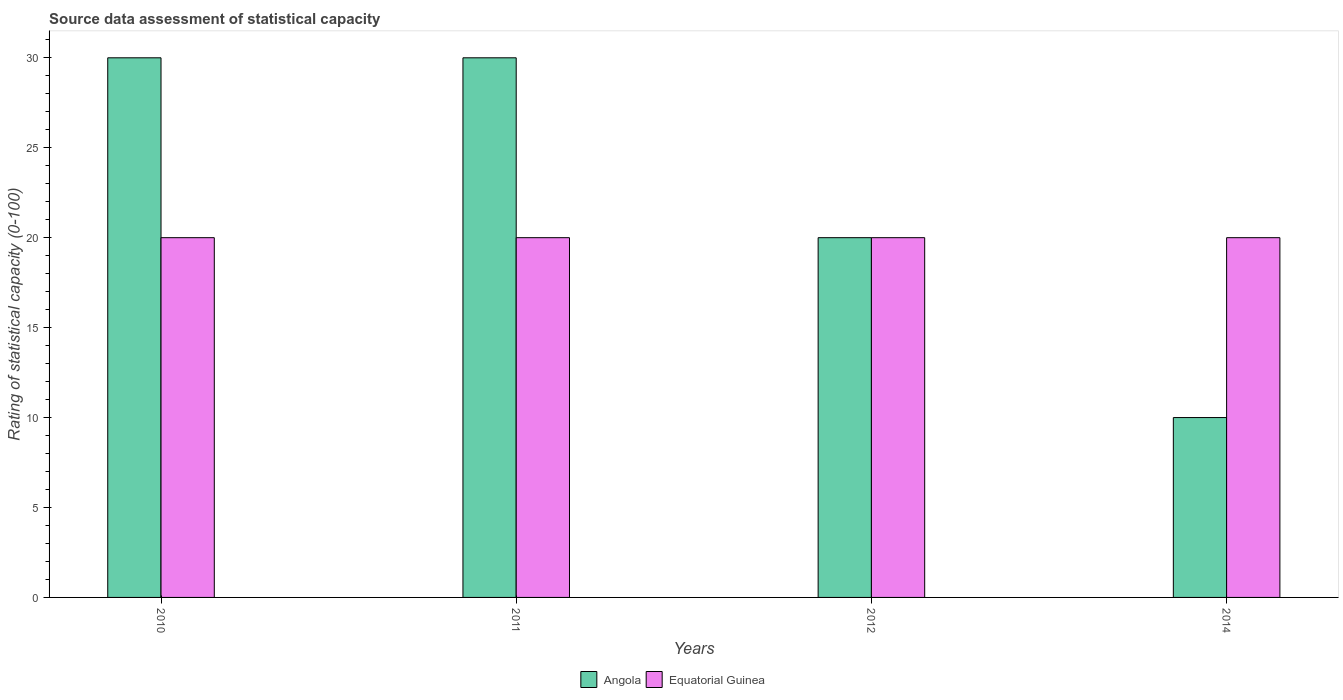How many groups of bars are there?
Your answer should be very brief. 4. How many bars are there on the 2nd tick from the right?
Provide a short and direct response. 2. In how many cases, is the number of bars for a given year not equal to the number of legend labels?
Keep it short and to the point. 0. What is the rating of statistical capacity in Angola in 2011?
Your response must be concise. 30. Across all years, what is the maximum rating of statistical capacity in Angola?
Make the answer very short. 30. Across all years, what is the minimum rating of statistical capacity in Angola?
Make the answer very short. 10. In which year was the rating of statistical capacity in Angola maximum?
Make the answer very short. 2010. What is the difference between the rating of statistical capacity in Equatorial Guinea in 2010 and that in 2011?
Ensure brevity in your answer.  0. What is the difference between the rating of statistical capacity in Equatorial Guinea in 2010 and the rating of statistical capacity in Angola in 2012?
Offer a terse response. 0. In the year 2012, what is the difference between the rating of statistical capacity in Angola and rating of statistical capacity in Equatorial Guinea?
Ensure brevity in your answer.  0. In how many years, is the rating of statistical capacity in Angola greater than 15?
Ensure brevity in your answer.  3. What is the ratio of the rating of statistical capacity in Equatorial Guinea in 2010 to that in 2011?
Your answer should be compact. 1. Is the rating of statistical capacity in Angola in 2010 less than that in 2012?
Your response must be concise. No. Is the difference between the rating of statistical capacity in Angola in 2010 and 2012 greater than the difference between the rating of statistical capacity in Equatorial Guinea in 2010 and 2012?
Provide a succinct answer. Yes. In how many years, is the rating of statistical capacity in Equatorial Guinea greater than the average rating of statistical capacity in Equatorial Guinea taken over all years?
Provide a succinct answer. 0. Is the sum of the rating of statistical capacity in Equatorial Guinea in 2012 and 2014 greater than the maximum rating of statistical capacity in Angola across all years?
Offer a very short reply. Yes. What does the 2nd bar from the left in 2012 represents?
Provide a short and direct response. Equatorial Guinea. What does the 2nd bar from the right in 2010 represents?
Give a very brief answer. Angola. How many bars are there?
Ensure brevity in your answer.  8. Are all the bars in the graph horizontal?
Provide a short and direct response. No. Are the values on the major ticks of Y-axis written in scientific E-notation?
Your answer should be compact. No. Does the graph contain any zero values?
Provide a succinct answer. No. Does the graph contain grids?
Your answer should be very brief. No. Where does the legend appear in the graph?
Your response must be concise. Bottom center. What is the title of the graph?
Your answer should be compact. Source data assessment of statistical capacity. Does "Burundi" appear as one of the legend labels in the graph?
Make the answer very short. No. What is the label or title of the X-axis?
Ensure brevity in your answer.  Years. What is the label or title of the Y-axis?
Ensure brevity in your answer.  Rating of statistical capacity (0-100). What is the Rating of statistical capacity (0-100) of Angola in 2012?
Your response must be concise. 20. What is the Rating of statistical capacity (0-100) in Angola in 2014?
Provide a succinct answer. 10. What is the Rating of statistical capacity (0-100) in Equatorial Guinea in 2014?
Your response must be concise. 20. Across all years, what is the maximum Rating of statistical capacity (0-100) of Angola?
Ensure brevity in your answer.  30. Across all years, what is the maximum Rating of statistical capacity (0-100) of Equatorial Guinea?
Offer a terse response. 20. What is the difference between the Rating of statistical capacity (0-100) of Equatorial Guinea in 2010 and that in 2011?
Give a very brief answer. 0. What is the difference between the Rating of statistical capacity (0-100) of Equatorial Guinea in 2010 and that in 2014?
Your response must be concise. 0. What is the difference between the Rating of statistical capacity (0-100) of Angola in 2011 and that in 2012?
Give a very brief answer. 10. What is the difference between the Rating of statistical capacity (0-100) of Angola in 2011 and that in 2014?
Your answer should be very brief. 20. What is the difference between the Rating of statistical capacity (0-100) of Equatorial Guinea in 2011 and that in 2014?
Ensure brevity in your answer.  0. What is the difference between the Rating of statistical capacity (0-100) in Equatorial Guinea in 2012 and that in 2014?
Offer a very short reply. 0. What is the difference between the Rating of statistical capacity (0-100) of Angola in 2010 and the Rating of statistical capacity (0-100) of Equatorial Guinea in 2014?
Keep it short and to the point. 10. What is the difference between the Rating of statistical capacity (0-100) of Angola in 2011 and the Rating of statistical capacity (0-100) of Equatorial Guinea in 2012?
Give a very brief answer. 10. What is the difference between the Rating of statistical capacity (0-100) of Angola in 2011 and the Rating of statistical capacity (0-100) of Equatorial Guinea in 2014?
Give a very brief answer. 10. What is the ratio of the Rating of statistical capacity (0-100) of Equatorial Guinea in 2010 to that in 2011?
Make the answer very short. 1. What is the ratio of the Rating of statistical capacity (0-100) in Angola in 2010 to that in 2012?
Your answer should be very brief. 1.5. What is the ratio of the Rating of statistical capacity (0-100) of Angola in 2010 to that in 2014?
Make the answer very short. 3. What is the ratio of the Rating of statistical capacity (0-100) of Angola in 2011 to that in 2012?
Ensure brevity in your answer.  1.5. What is the ratio of the Rating of statistical capacity (0-100) in Angola in 2011 to that in 2014?
Provide a succinct answer. 3. What is the ratio of the Rating of statistical capacity (0-100) of Equatorial Guinea in 2011 to that in 2014?
Give a very brief answer. 1. What is the ratio of the Rating of statistical capacity (0-100) of Equatorial Guinea in 2012 to that in 2014?
Give a very brief answer. 1. What is the difference between the highest and the second highest Rating of statistical capacity (0-100) of Angola?
Give a very brief answer. 0. What is the difference between the highest and the second highest Rating of statistical capacity (0-100) of Equatorial Guinea?
Your response must be concise. 0. What is the difference between the highest and the lowest Rating of statistical capacity (0-100) in Angola?
Provide a succinct answer. 20. 